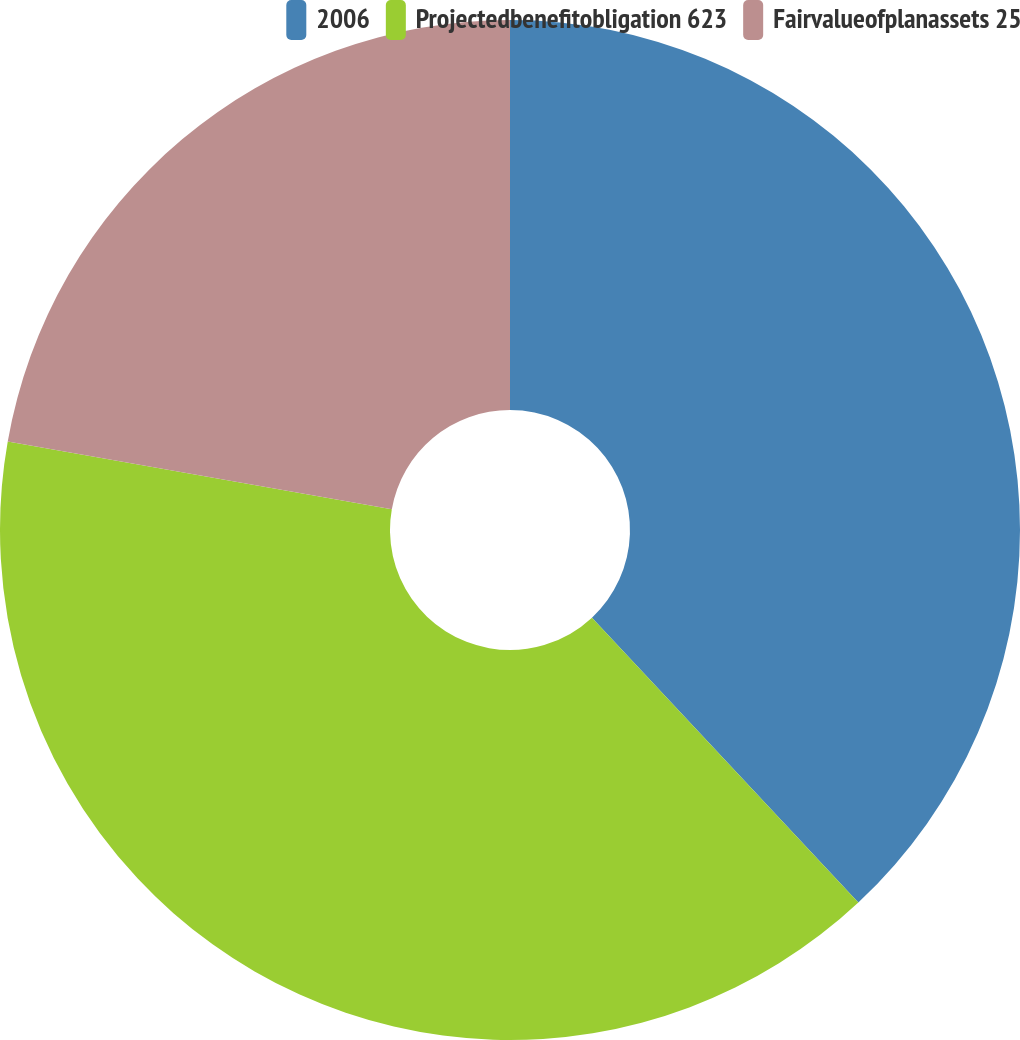Convert chart to OTSL. <chart><loc_0><loc_0><loc_500><loc_500><pie_chart><fcel>2006<fcel>Projectedbenefitobligation 623<fcel>Fairvalueofplanassets 25<nl><fcel>38.03%<fcel>39.74%<fcel>22.22%<nl></chart> 